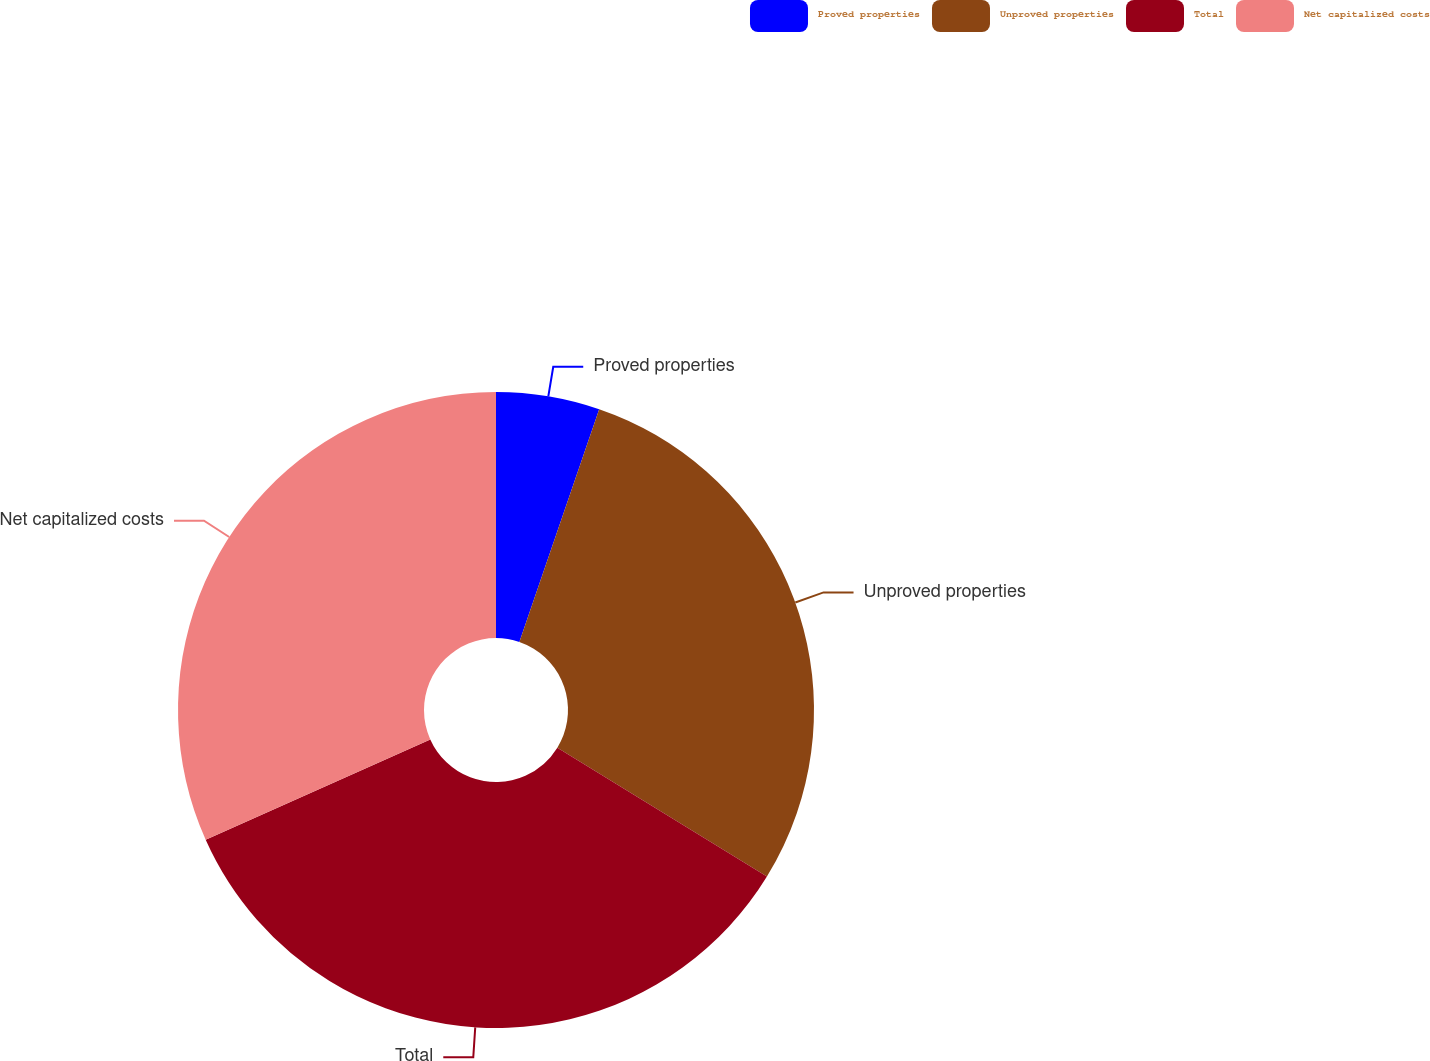Convert chart to OTSL. <chart><loc_0><loc_0><loc_500><loc_500><pie_chart><fcel>Proved properties<fcel>Unproved properties<fcel>Total<fcel>Net capitalized costs<nl><fcel>5.26%<fcel>28.51%<fcel>34.54%<fcel>31.69%<nl></chart> 